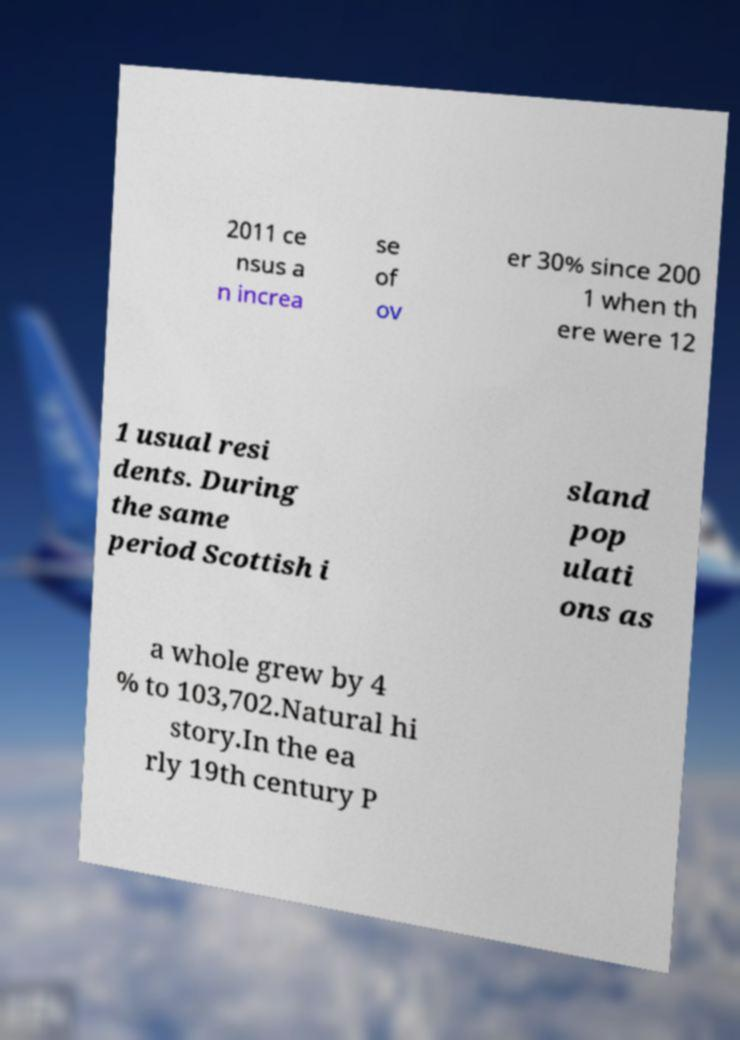Could you extract and type out the text from this image? 2011 ce nsus a n increa se of ov er 30% since 200 1 when th ere were 12 1 usual resi dents. During the same period Scottish i sland pop ulati ons as a whole grew by 4 % to 103,702.Natural hi story.In the ea rly 19th century P 